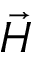Convert formula to latex. <formula><loc_0><loc_0><loc_500><loc_500>\ V e c { H }</formula> 